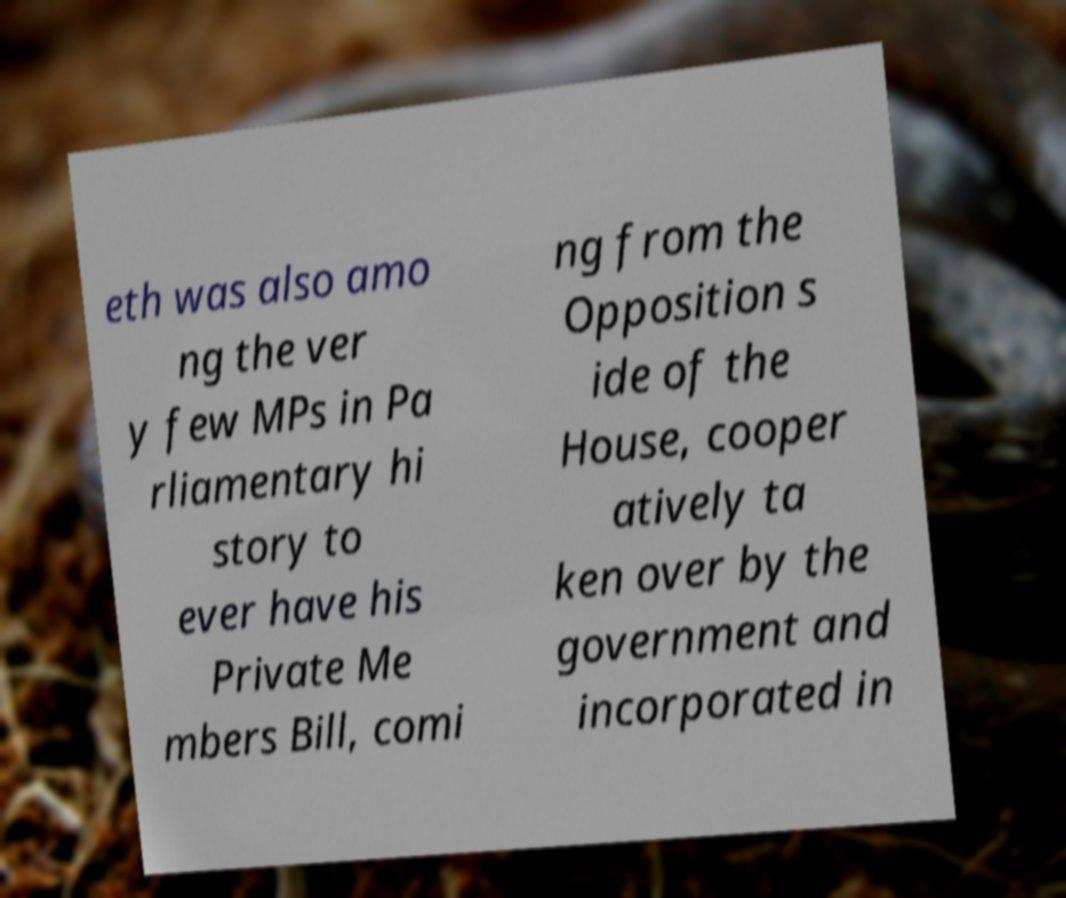Can you read and provide the text displayed in the image?This photo seems to have some interesting text. Can you extract and type it out for me? eth was also amo ng the ver y few MPs in Pa rliamentary hi story to ever have his Private Me mbers Bill, comi ng from the Opposition s ide of the House, cooper atively ta ken over by the government and incorporated in 